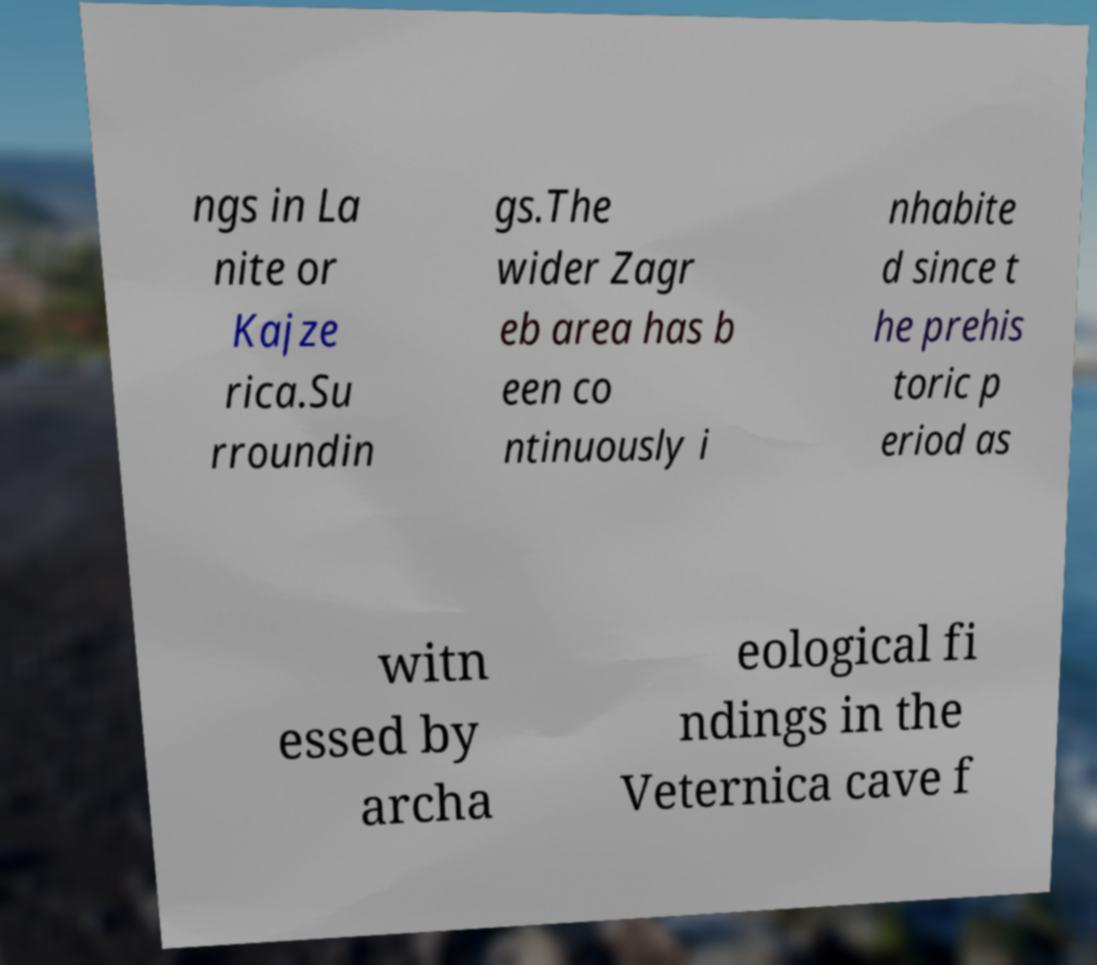Can you read and provide the text displayed in the image?This photo seems to have some interesting text. Can you extract and type it out for me? ngs in La nite or Kajze rica.Su rroundin gs.The wider Zagr eb area has b een co ntinuously i nhabite d since t he prehis toric p eriod as witn essed by archa eological fi ndings in the Veternica cave f 